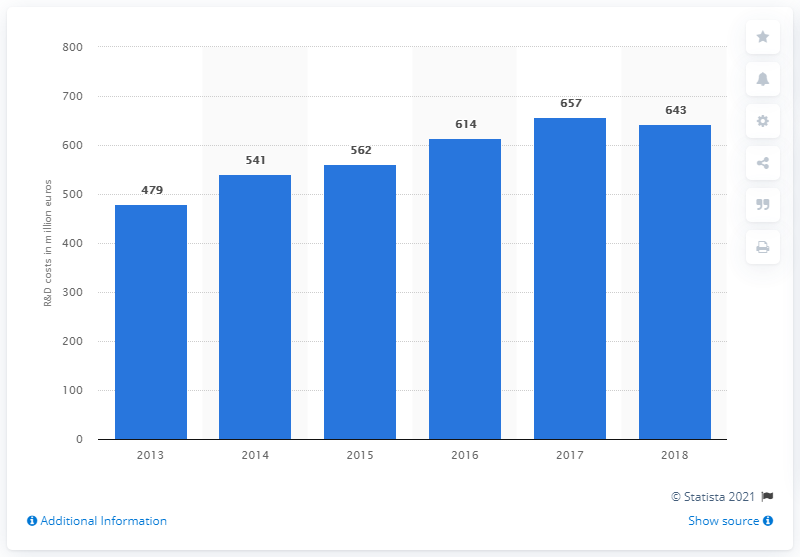What does the trend in the graph suggest about Ferrari's investment in R&D over the years? The trend in the graph shows a steady increase in Ferrari's investment in R&D from 2013 to 2017, suggesting a strategic commitment to innovation and development. The peak in 2017, followed by a slight decrease in 2018, might indicate a cycle of heavy investment followed by a period of evaluation and implementation of the developed technologies. 